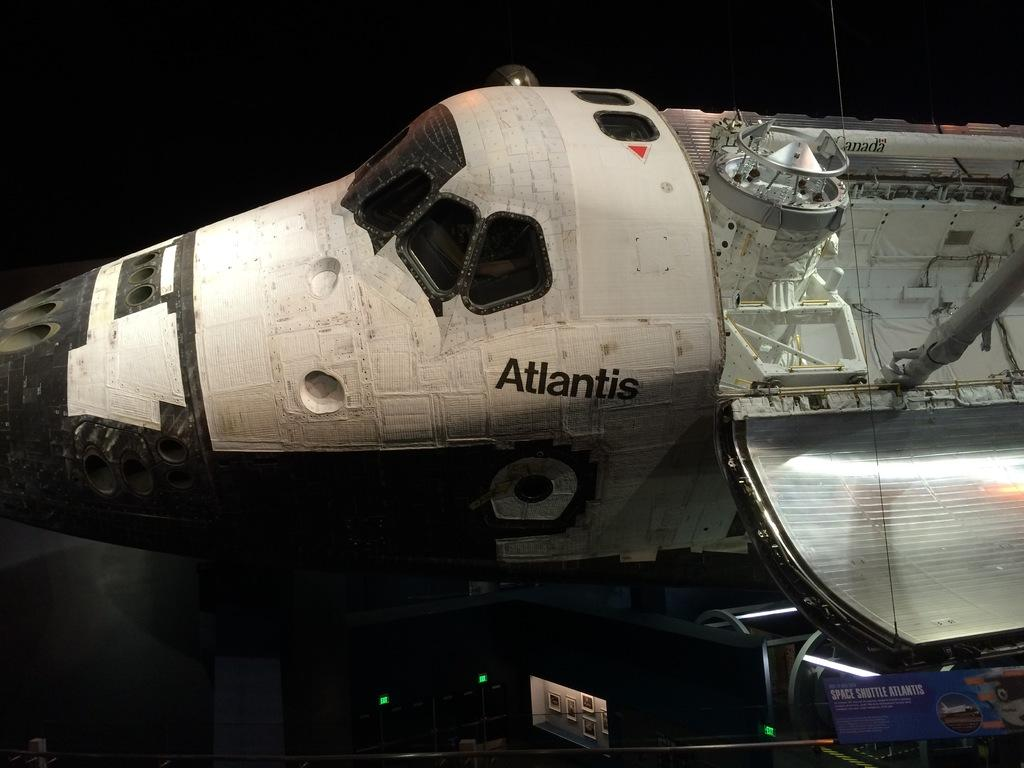<image>
Create a compact narrative representing the image presented. The body of Atlantis, an airplane or shuttle, is shown open. 